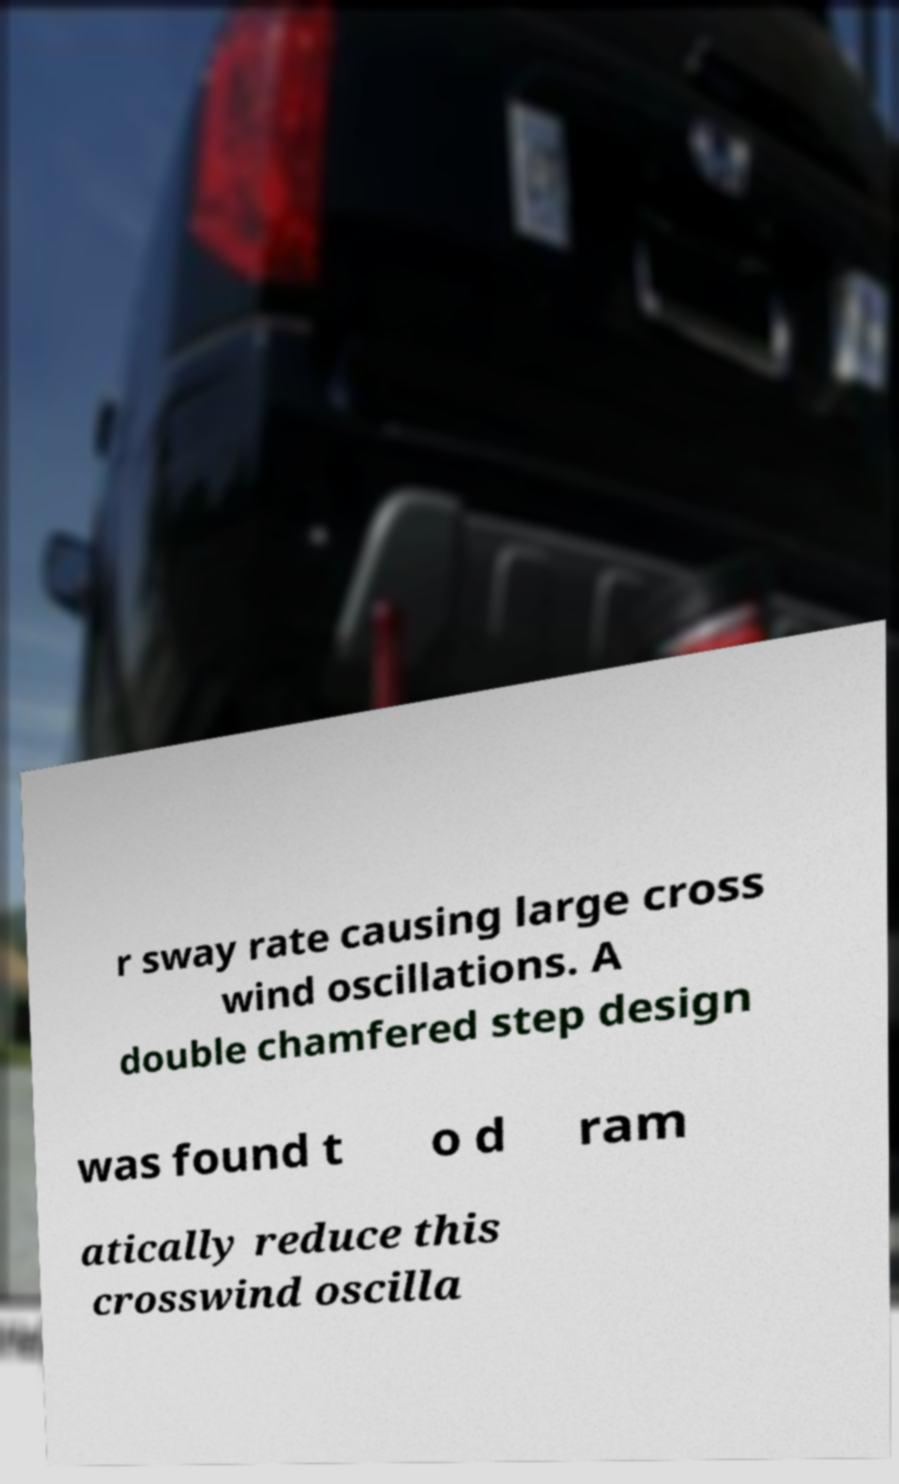For documentation purposes, I need the text within this image transcribed. Could you provide that? r sway rate causing large cross wind oscillations. A double chamfered step design was found t o d ram atically reduce this crosswind oscilla 